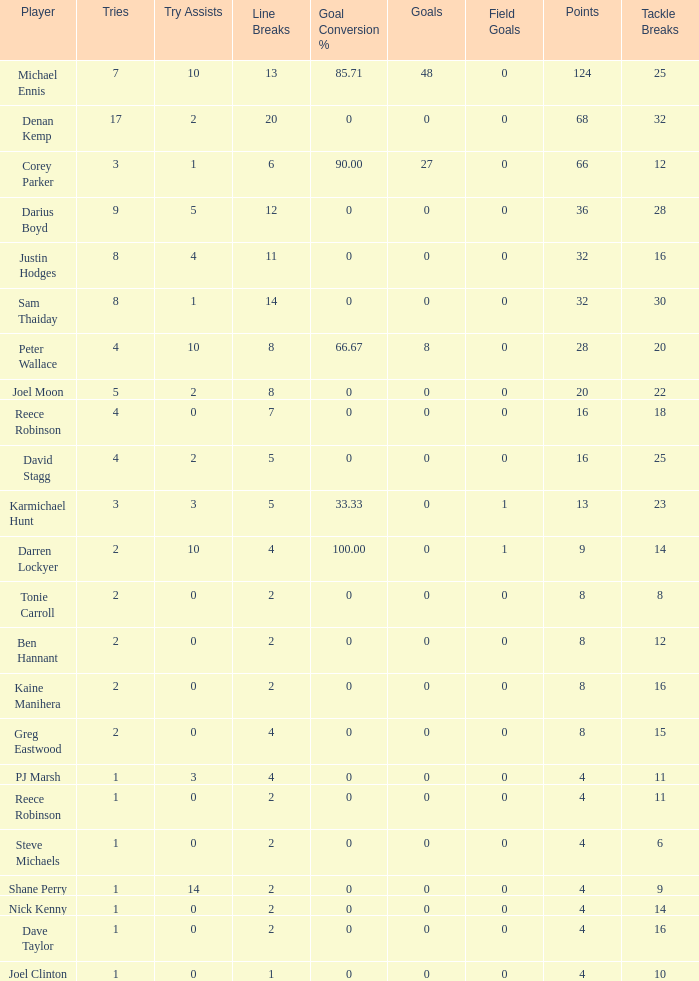What is the total number of field goals of Denan Kemp, who has more than 4 tries, more than 32 points, and 0 goals? 1.0. 